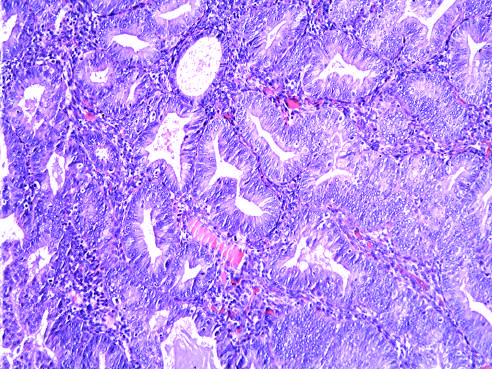what is seen as glandular crowding and cellular atypia?
Answer the question using a single word or phrase. Hyperplasia without atypia 